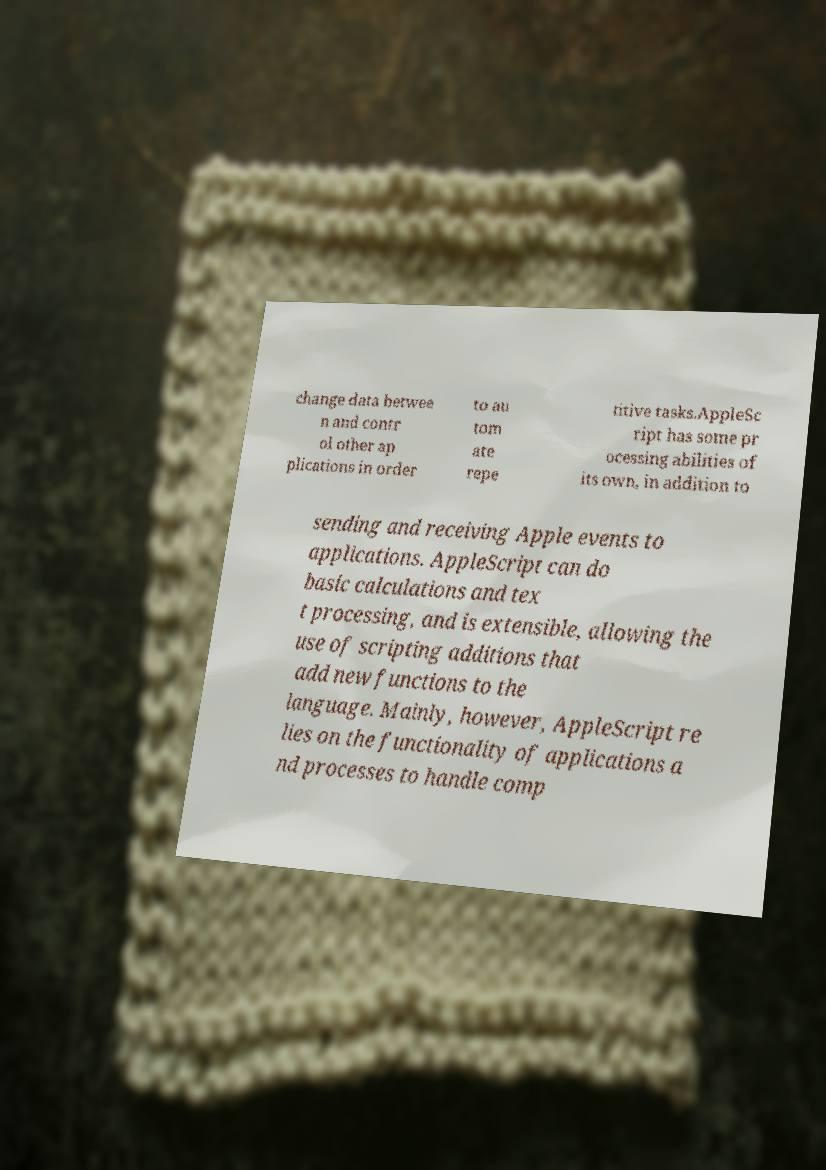Please read and relay the text visible in this image. What does it say? change data betwee n and contr ol other ap plications in order to au tom ate repe titive tasks.AppleSc ript has some pr ocessing abilities of its own, in addition to sending and receiving Apple events to applications. AppleScript can do basic calculations and tex t processing, and is extensible, allowing the use of scripting additions that add new functions to the language. Mainly, however, AppleScript re lies on the functionality of applications a nd processes to handle comp 